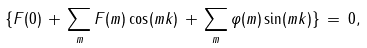Convert formula to latex. <formula><loc_0><loc_0><loc_500><loc_500>\{ F ( 0 ) \, + \, \sum _ { m } F ( m ) \cos ( m k ) \, + \, \sum _ { m } \varphi ( m ) \sin ( m k ) \} \, = \, 0 ,</formula> 